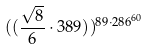<formula> <loc_0><loc_0><loc_500><loc_500>( ( \frac { \sqrt { 8 } } { 6 } \cdot 3 8 9 ) ) ^ { 8 9 \cdot 2 8 6 ^ { 6 0 } }</formula> 